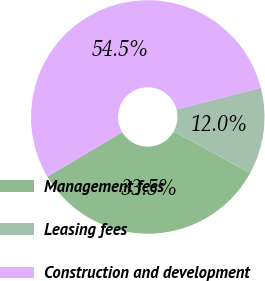<chart> <loc_0><loc_0><loc_500><loc_500><pie_chart><fcel>Management fees<fcel>Leasing fees<fcel>Construction and development<nl><fcel>33.48%<fcel>12.02%<fcel>54.51%<nl></chart> 